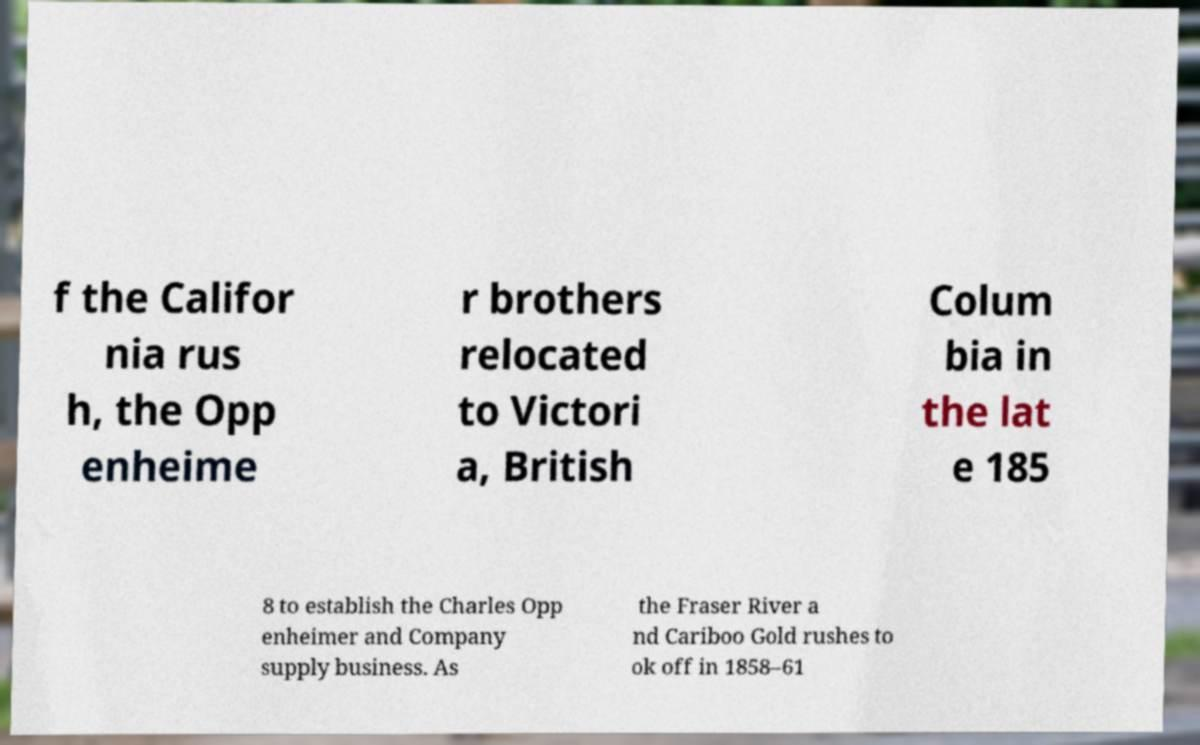Please read and relay the text visible in this image. What does it say? f the Califor nia rus h, the Opp enheime r brothers relocated to Victori a, British Colum bia in the lat e 185 8 to establish the Charles Opp enheimer and Company supply business. As the Fraser River a nd Cariboo Gold rushes to ok off in 1858–61 